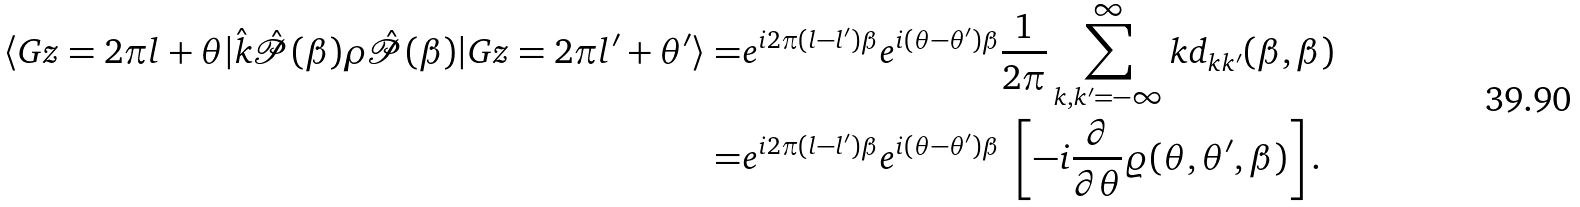<formula> <loc_0><loc_0><loc_500><loc_500>\langle G z = 2 \pi l + \theta | \hat { k } \hat { \mathcal { P } } ( \beta ) \rho \hat { \mathcal { P } } ( \beta ) | G z = 2 \pi l ^ { \prime } + \theta ^ { \prime } \rangle = & e ^ { i 2 \pi ( l - l ^ { \prime } ) \beta } e ^ { i ( \theta - \theta ^ { \prime } ) \beta } \frac { 1 } { 2 \pi } \sum _ { k , k ^ { \prime } = - \infty } ^ { \infty } k d _ { k k ^ { \prime } } ( \beta , \beta ) \\ = & e ^ { i 2 \pi ( l - l ^ { \prime } ) \beta } e ^ { i ( \theta - \theta ^ { \prime } ) \beta } \ \left [ - i \frac { \partial } { \partial \theta } \varrho ( \theta , \theta ^ { \prime } , \beta ) \right ] .</formula> 